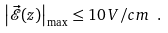Convert formula to latex. <formula><loc_0><loc_0><loc_500><loc_500>\left | \vec { \mathcal { E } } ( z ) \right | _ { \max } \leq 1 0 \, V / c m \ .</formula> 